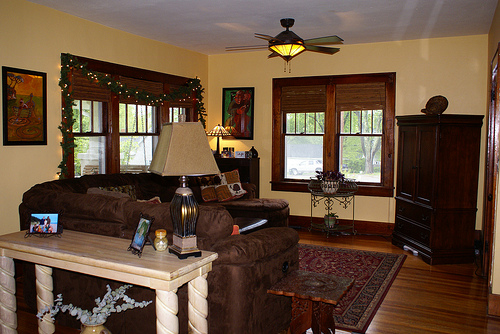Please provide the bounding box coordinate of the region this sentence describes: the doors are closed. Coordinates: [0.81, 0.42, 0.85, 0.56]. The area showing the closed doors. 